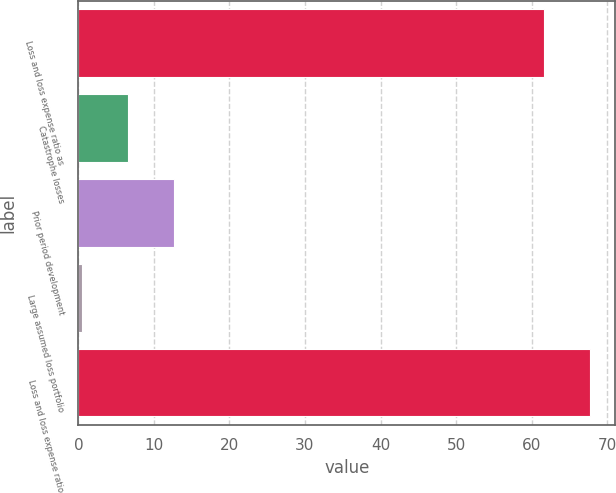Convert chart. <chart><loc_0><loc_0><loc_500><loc_500><bar_chart><fcel>Loss and loss expense ratio as<fcel>Catastrophe losses<fcel>Prior period development<fcel>Large assumed loss portfolio<fcel>Loss and loss expense ratio<nl><fcel>61.6<fcel>6.61<fcel>12.72<fcel>0.5<fcel>67.71<nl></chart> 